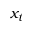<formula> <loc_0><loc_0><loc_500><loc_500>x _ { t }</formula> 